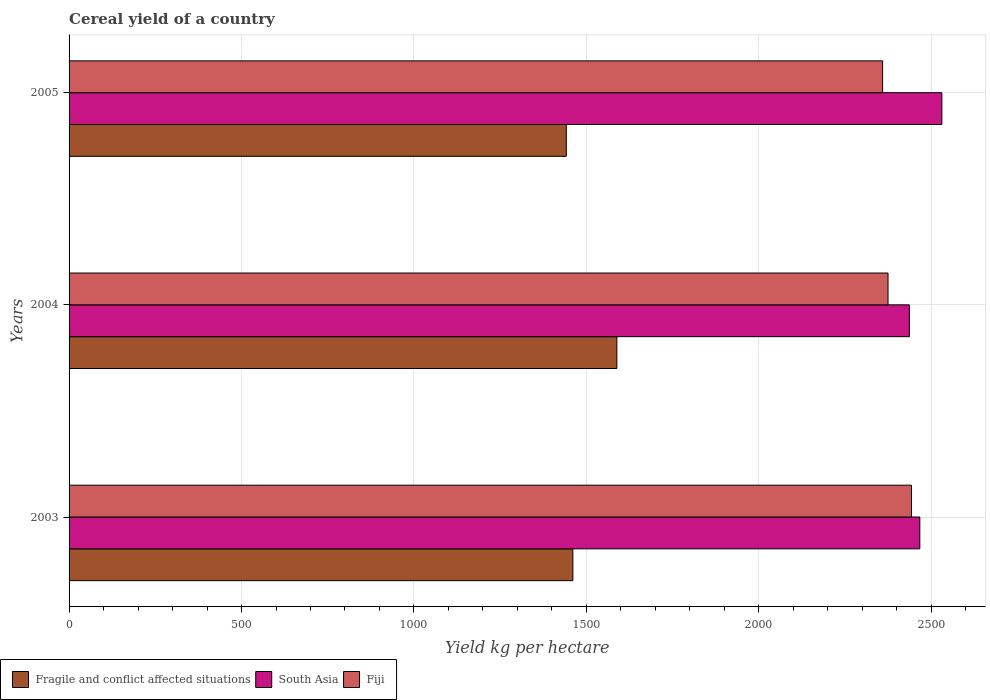How many groups of bars are there?
Your answer should be compact. 3. Are the number of bars per tick equal to the number of legend labels?
Keep it short and to the point. Yes. How many bars are there on the 2nd tick from the top?
Offer a very short reply. 3. What is the total cereal yield in South Asia in 2005?
Offer a very short reply. 2530.63. Across all years, what is the maximum total cereal yield in Fragile and conflict affected situations?
Your response must be concise. 1588.37. Across all years, what is the minimum total cereal yield in Fiji?
Offer a terse response. 2358.86. In which year was the total cereal yield in Fiji maximum?
Provide a succinct answer. 2003. What is the total total cereal yield in Fragile and conflict affected situations in the graph?
Provide a short and direct response. 4490.91. What is the difference between the total cereal yield in Fragile and conflict affected situations in 2004 and that in 2005?
Offer a very short reply. 146.61. What is the difference between the total cereal yield in South Asia in 2004 and the total cereal yield in Fragile and conflict affected situations in 2005?
Ensure brevity in your answer.  994.69. What is the average total cereal yield in South Asia per year?
Your response must be concise. 2477.94. In the year 2003, what is the difference between the total cereal yield in Fiji and total cereal yield in South Asia?
Provide a short and direct response. -24.19. In how many years, is the total cereal yield in Fiji greater than 1300 kg per hectare?
Your response must be concise. 3. What is the ratio of the total cereal yield in Fragile and conflict affected situations in 2003 to that in 2005?
Your answer should be compact. 1.01. Is the total cereal yield in Fiji in 2003 less than that in 2004?
Make the answer very short. No. Is the difference between the total cereal yield in Fiji in 2003 and 2004 greater than the difference between the total cereal yield in South Asia in 2003 and 2004?
Provide a succinct answer. Yes. What is the difference between the highest and the second highest total cereal yield in South Asia?
Your answer should be very brief. 63.91. What is the difference between the highest and the lowest total cereal yield in Fragile and conflict affected situations?
Your answer should be very brief. 146.61. Is the sum of the total cereal yield in Fiji in 2004 and 2005 greater than the maximum total cereal yield in South Asia across all years?
Keep it short and to the point. Yes. What does the 3rd bar from the top in 2005 represents?
Make the answer very short. Fragile and conflict affected situations. What does the 1st bar from the bottom in 2003 represents?
Your response must be concise. Fragile and conflict affected situations. How many bars are there?
Make the answer very short. 9. Are all the bars in the graph horizontal?
Provide a short and direct response. Yes. Are the values on the major ticks of X-axis written in scientific E-notation?
Give a very brief answer. No. Does the graph contain grids?
Provide a short and direct response. Yes. Where does the legend appear in the graph?
Your answer should be very brief. Bottom left. How many legend labels are there?
Give a very brief answer. 3. How are the legend labels stacked?
Provide a succinct answer. Horizontal. What is the title of the graph?
Offer a very short reply. Cereal yield of a country. Does "Andorra" appear as one of the legend labels in the graph?
Your answer should be compact. No. What is the label or title of the X-axis?
Offer a very short reply. Yield kg per hectare. What is the Yield kg per hectare in Fragile and conflict affected situations in 2003?
Your response must be concise. 1460.77. What is the Yield kg per hectare in South Asia in 2003?
Offer a very short reply. 2466.72. What is the Yield kg per hectare in Fiji in 2003?
Your answer should be very brief. 2442.53. What is the Yield kg per hectare of Fragile and conflict affected situations in 2004?
Keep it short and to the point. 1588.37. What is the Yield kg per hectare of South Asia in 2004?
Keep it short and to the point. 2436.46. What is the Yield kg per hectare in Fiji in 2004?
Ensure brevity in your answer.  2374.59. What is the Yield kg per hectare in Fragile and conflict affected situations in 2005?
Keep it short and to the point. 1441.77. What is the Yield kg per hectare in South Asia in 2005?
Ensure brevity in your answer.  2530.63. What is the Yield kg per hectare in Fiji in 2005?
Make the answer very short. 2358.86. Across all years, what is the maximum Yield kg per hectare in Fragile and conflict affected situations?
Provide a succinct answer. 1588.37. Across all years, what is the maximum Yield kg per hectare in South Asia?
Make the answer very short. 2530.63. Across all years, what is the maximum Yield kg per hectare of Fiji?
Give a very brief answer. 2442.53. Across all years, what is the minimum Yield kg per hectare in Fragile and conflict affected situations?
Provide a short and direct response. 1441.77. Across all years, what is the minimum Yield kg per hectare of South Asia?
Your response must be concise. 2436.46. Across all years, what is the minimum Yield kg per hectare of Fiji?
Provide a succinct answer. 2358.86. What is the total Yield kg per hectare in Fragile and conflict affected situations in the graph?
Make the answer very short. 4490.91. What is the total Yield kg per hectare in South Asia in the graph?
Your response must be concise. 7433.81. What is the total Yield kg per hectare of Fiji in the graph?
Your answer should be compact. 7175.98. What is the difference between the Yield kg per hectare in Fragile and conflict affected situations in 2003 and that in 2004?
Offer a very short reply. -127.6. What is the difference between the Yield kg per hectare of South Asia in 2003 and that in 2004?
Your response must be concise. 30.26. What is the difference between the Yield kg per hectare of Fiji in 2003 and that in 2004?
Provide a succinct answer. 67.93. What is the difference between the Yield kg per hectare in Fragile and conflict affected situations in 2003 and that in 2005?
Provide a succinct answer. 19.01. What is the difference between the Yield kg per hectare in South Asia in 2003 and that in 2005?
Ensure brevity in your answer.  -63.91. What is the difference between the Yield kg per hectare in Fiji in 2003 and that in 2005?
Your answer should be compact. 83.66. What is the difference between the Yield kg per hectare in Fragile and conflict affected situations in 2004 and that in 2005?
Your response must be concise. 146.61. What is the difference between the Yield kg per hectare of South Asia in 2004 and that in 2005?
Offer a very short reply. -94.17. What is the difference between the Yield kg per hectare in Fiji in 2004 and that in 2005?
Give a very brief answer. 15.73. What is the difference between the Yield kg per hectare in Fragile and conflict affected situations in 2003 and the Yield kg per hectare in South Asia in 2004?
Offer a very short reply. -975.69. What is the difference between the Yield kg per hectare of Fragile and conflict affected situations in 2003 and the Yield kg per hectare of Fiji in 2004?
Provide a succinct answer. -913.82. What is the difference between the Yield kg per hectare in South Asia in 2003 and the Yield kg per hectare in Fiji in 2004?
Offer a terse response. 92.13. What is the difference between the Yield kg per hectare of Fragile and conflict affected situations in 2003 and the Yield kg per hectare of South Asia in 2005?
Your response must be concise. -1069.86. What is the difference between the Yield kg per hectare in Fragile and conflict affected situations in 2003 and the Yield kg per hectare in Fiji in 2005?
Offer a terse response. -898.09. What is the difference between the Yield kg per hectare in South Asia in 2003 and the Yield kg per hectare in Fiji in 2005?
Offer a terse response. 107.86. What is the difference between the Yield kg per hectare in Fragile and conflict affected situations in 2004 and the Yield kg per hectare in South Asia in 2005?
Make the answer very short. -942.26. What is the difference between the Yield kg per hectare of Fragile and conflict affected situations in 2004 and the Yield kg per hectare of Fiji in 2005?
Your answer should be very brief. -770.49. What is the difference between the Yield kg per hectare of South Asia in 2004 and the Yield kg per hectare of Fiji in 2005?
Make the answer very short. 77.59. What is the average Yield kg per hectare of Fragile and conflict affected situations per year?
Make the answer very short. 1496.97. What is the average Yield kg per hectare of South Asia per year?
Make the answer very short. 2477.94. What is the average Yield kg per hectare in Fiji per year?
Provide a short and direct response. 2391.99. In the year 2003, what is the difference between the Yield kg per hectare of Fragile and conflict affected situations and Yield kg per hectare of South Asia?
Your answer should be compact. -1005.95. In the year 2003, what is the difference between the Yield kg per hectare of Fragile and conflict affected situations and Yield kg per hectare of Fiji?
Your answer should be compact. -981.75. In the year 2003, what is the difference between the Yield kg per hectare in South Asia and Yield kg per hectare in Fiji?
Give a very brief answer. 24.19. In the year 2004, what is the difference between the Yield kg per hectare in Fragile and conflict affected situations and Yield kg per hectare in South Asia?
Provide a succinct answer. -848.08. In the year 2004, what is the difference between the Yield kg per hectare of Fragile and conflict affected situations and Yield kg per hectare of Fiji?
Provide a succinct answer. -786.22. In the year 2004, what is the difference between the Yield kg per hectare in South Asia and Yield kg per hectare in Fiji?
Keep it short and to the point. 61.87. In the year 2005, what is the difference between the Yield kg per hectare of Fragile and conflict affected situations and Yield kg per hectare of South Asia?
Your answer should be very brief. -1088.86. In the year 2005, what is the difference between the Yield kg per hectare in Fragile and conflict affected situations and Yield kg per hectare in Fiji?
Make the answer very short. -917.1. In the year 2005, what is the difference between the Yield kg per hectare in South Asia and Yield kg per hectare in Fiji?
Your response must be concise. 171.77. What is the ratio of the Yield kg per hectare in Fragile and conflict affected situations in 2003 to that in 2004?
Your answer should be compact. 0.92. What is the ratio of the Yield kg per hectare of South Asia in 2003 to that in 2004?
Provide a succinct answer. 1.01. What is the ratio of the Yield kg per hectare of Fiji in 2003 to that in 2004?
Make the answer very short. 1.03. What is the ratio of the Yield kg per hectare of Fragile and conflict affected situations in 2003 to that in 2005?
Ensure brevity in your answer.  1.01. What is the ratio of the Yield kg per hectare in South Asia in 2003 to that in 2005?
Offer a very short reply. 0.97. What is the ratio of the Yield kg per hectare of Fiji in 2003 to that in 2005?
Make the answer very short. 1.04. What is the ratio of the Yield kg per hectare of Fragile and conflict affected situations in 2004 to that in 2005?
Provide a succinct answer. 1.1. What is the ratio of the Yield kg per hectare in South Asia in 2004 to that in 2005?
Offer a terse response. 0.96. What is the difference between the highest and the second highest Yield kg per hectare of Fragile and conflict affected situations?
Your answer should be very brief. 127.6. What is the difference between the highest and the second highest Yield kg per hectare of South Asia?
Offer a terse response. 63.91. What is the difference between the highest and the second highest Yield kg per hectare in Fiji?
Provide a short and direct response. 67.93. What is the difference between the highest and the lowest Yield kg per hectare of Fragile and conflict affected situations?
Offer a very short reply. 146.61. What is the difference between the highest and the lowest Yield kg per hectare of South Asia?
Offer a very short reply. 94.17. What is the difference between the highest and the lowest Yield kg per hectare of Fiji?
Your answer should be very brief. 83.66. 